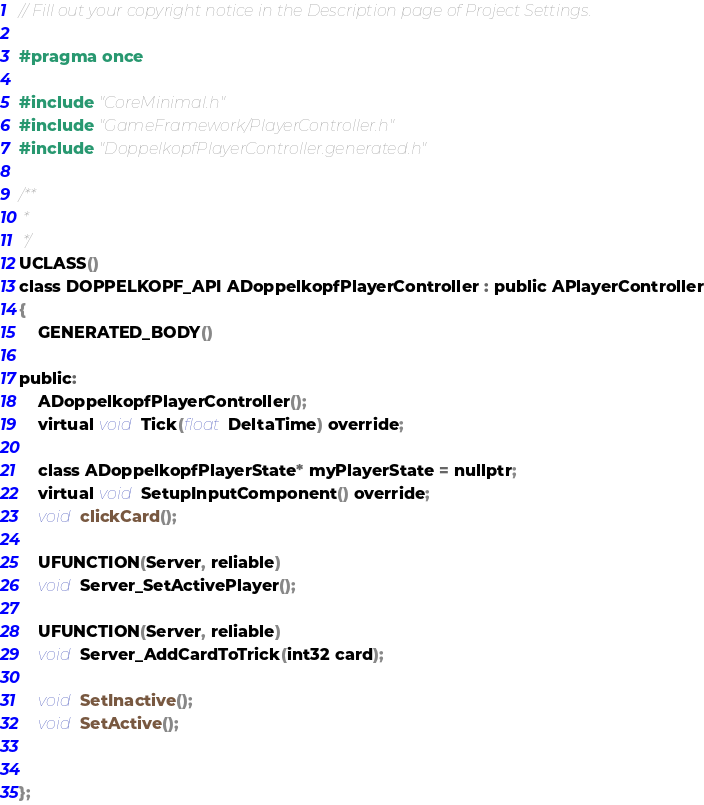<code> <loc_0><loc_0><loc_500><loc_500><_C_>// Fill out your copyright notice in the Description page of Project Settings.

#pragma once

#include "CoreMinimal.h"
#include "GameFramework/PlayerController.h"
#include "DoppelkopfPlayerController.generated.h"

/**
 * 
 */
UCLASS()
class DOPPELKOPF_API ADoppelkopfPlayerController : public APlayerController
{
	GENERATED_BODY()

public:
    ADoppelkopfPlayerController();
    virtual void Tick(float DeltaTime) override;

    class ADoppelkopfPlayerState* myPlayerState = nullptr;
    virtual void SetupInputComponent() override;
    void clickCard();

    UFUNCTION(Server, reliable)
	void Server_SetActivePlayer();

	UFUNCTION(Server, reliable)
	void Server_AddCardToTrick(int32 card);

    void SetInactive();
    void SetActive();

       
};
</code> 